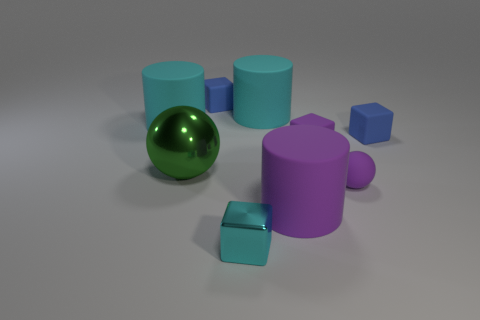What shape is the tiny thing that is left of the big purple cylinder and behind the large green object?
Give a very brief answer. Cube. There is a block that is to the left of the small cyan block; what color is it?
Make the answer very short. Blue. Are there any other things that are the same color as the large metal object?
Ensure brevity in your answer.  No. Do the purple sphere and the green thing have the same size?
Give a very brief answer. No. What is the size of the block that is to the left of the purple sphere and behind the tiny purple rubber block?
Ensure brevity in your answer.  Small. How many other big spheres are the same material as the green ball?
Your answer should be compact. 0. There is a big rubber object that is the same color as the tiny matte sphere; what is its shape?
Keep it short and to the point. Cylinder. The metal sphere has what color?
Provide a short and direct response. Green. There is a cyan matte thing that is on the right side of the tiny metallic thing; is its shape the same as the big green shiny thing?
Make the answer very short. No. What number of things are tiny cubes that are behind the large purple matte object or rubber spheres?
Give a very brief answer. 4. 